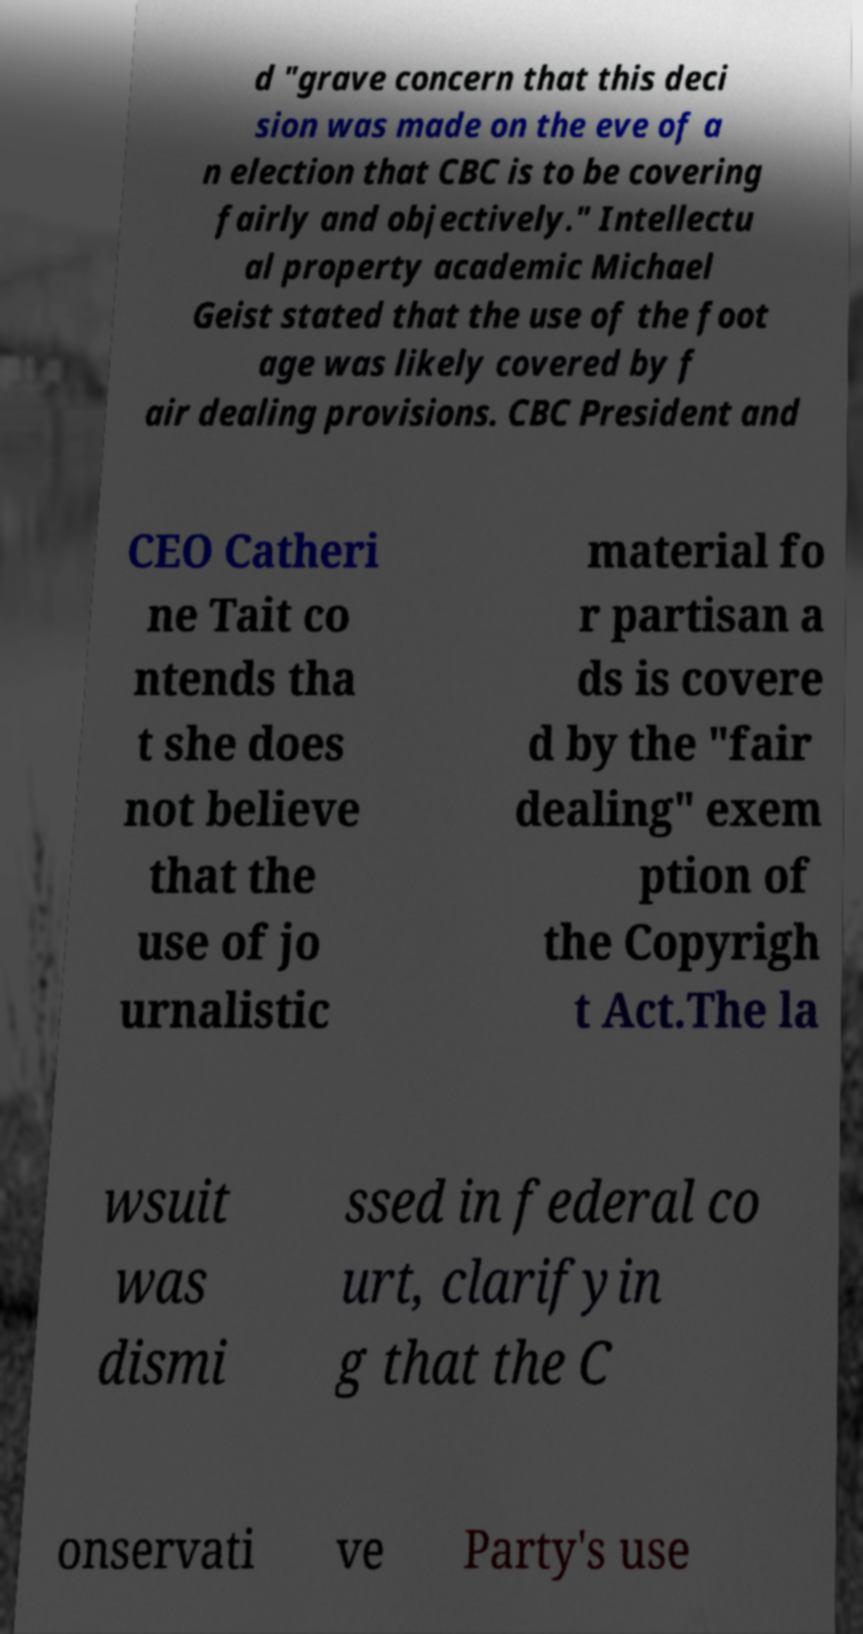Can you read and provide the text displayed in the image?This photo seems to have some interesting text. Can you extract and type it out for me? d "grave concern that this deci sion was made on the eve of a n election that CBC is to be covering fairly and objectively." Intellectu al property academic Michael Geist stated that the use of the foot age was likely covered by f air dealing provisions. CBC President and CEO Catheri ne Tait co ntends tha t she does not believe that the use of jo urnalistic material fo r partisan a ds is covere d by the "fair dealing" exem ption of the Copyrigh t Act.The la wsuit was dismi ssed in federal co urt, clarifyin g that the C onservati ve Party's use 